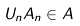<formula> <loc_0><loc_0><loc_500><loc_500>U _ { n } A _ { n } \in A</formula> 